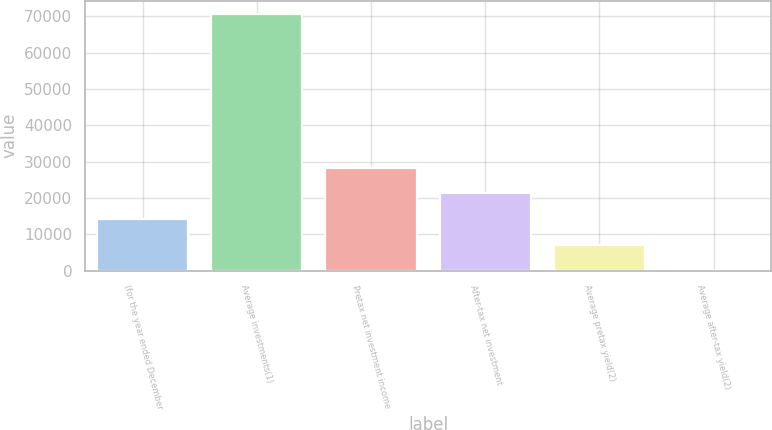Convert chart to OTSL. <chart><loc_0><loc_0><loc_500><loc_500><bar_chart><fcel>(for the year ended December<fcel>Average investments(1)<fcel>Pretax net investment income<fcel>After-tax net investment<fcel>Average pretax yield(2)<fcel>Average after-tax yield(2)<nl><fcel>14141.9<fcel>70697<fcel>28280.7<fcel>21211.3<fcel>7072.49<fcel>3.1<nl></chart> 